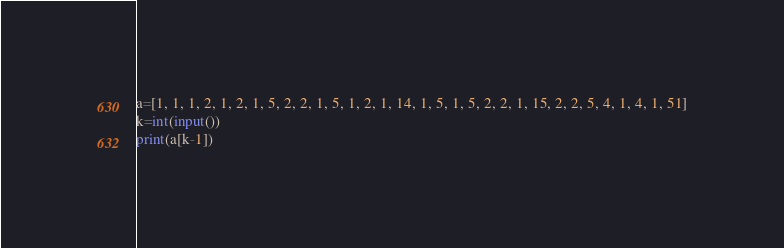<code> <loc_0><loc_0><loc_500><loc_500><_Python_>a=[1, 1, 1, 2, 1, 2, 1, 5, 2, 2, 1, 5, 1, 2, 1, 14, 1, 5, 1, 5, 2, 2, 1, 15, 2, 2, 5, 4, 1, 4, 1, 51]
k=int(input())
print(a[k-1])</code> 